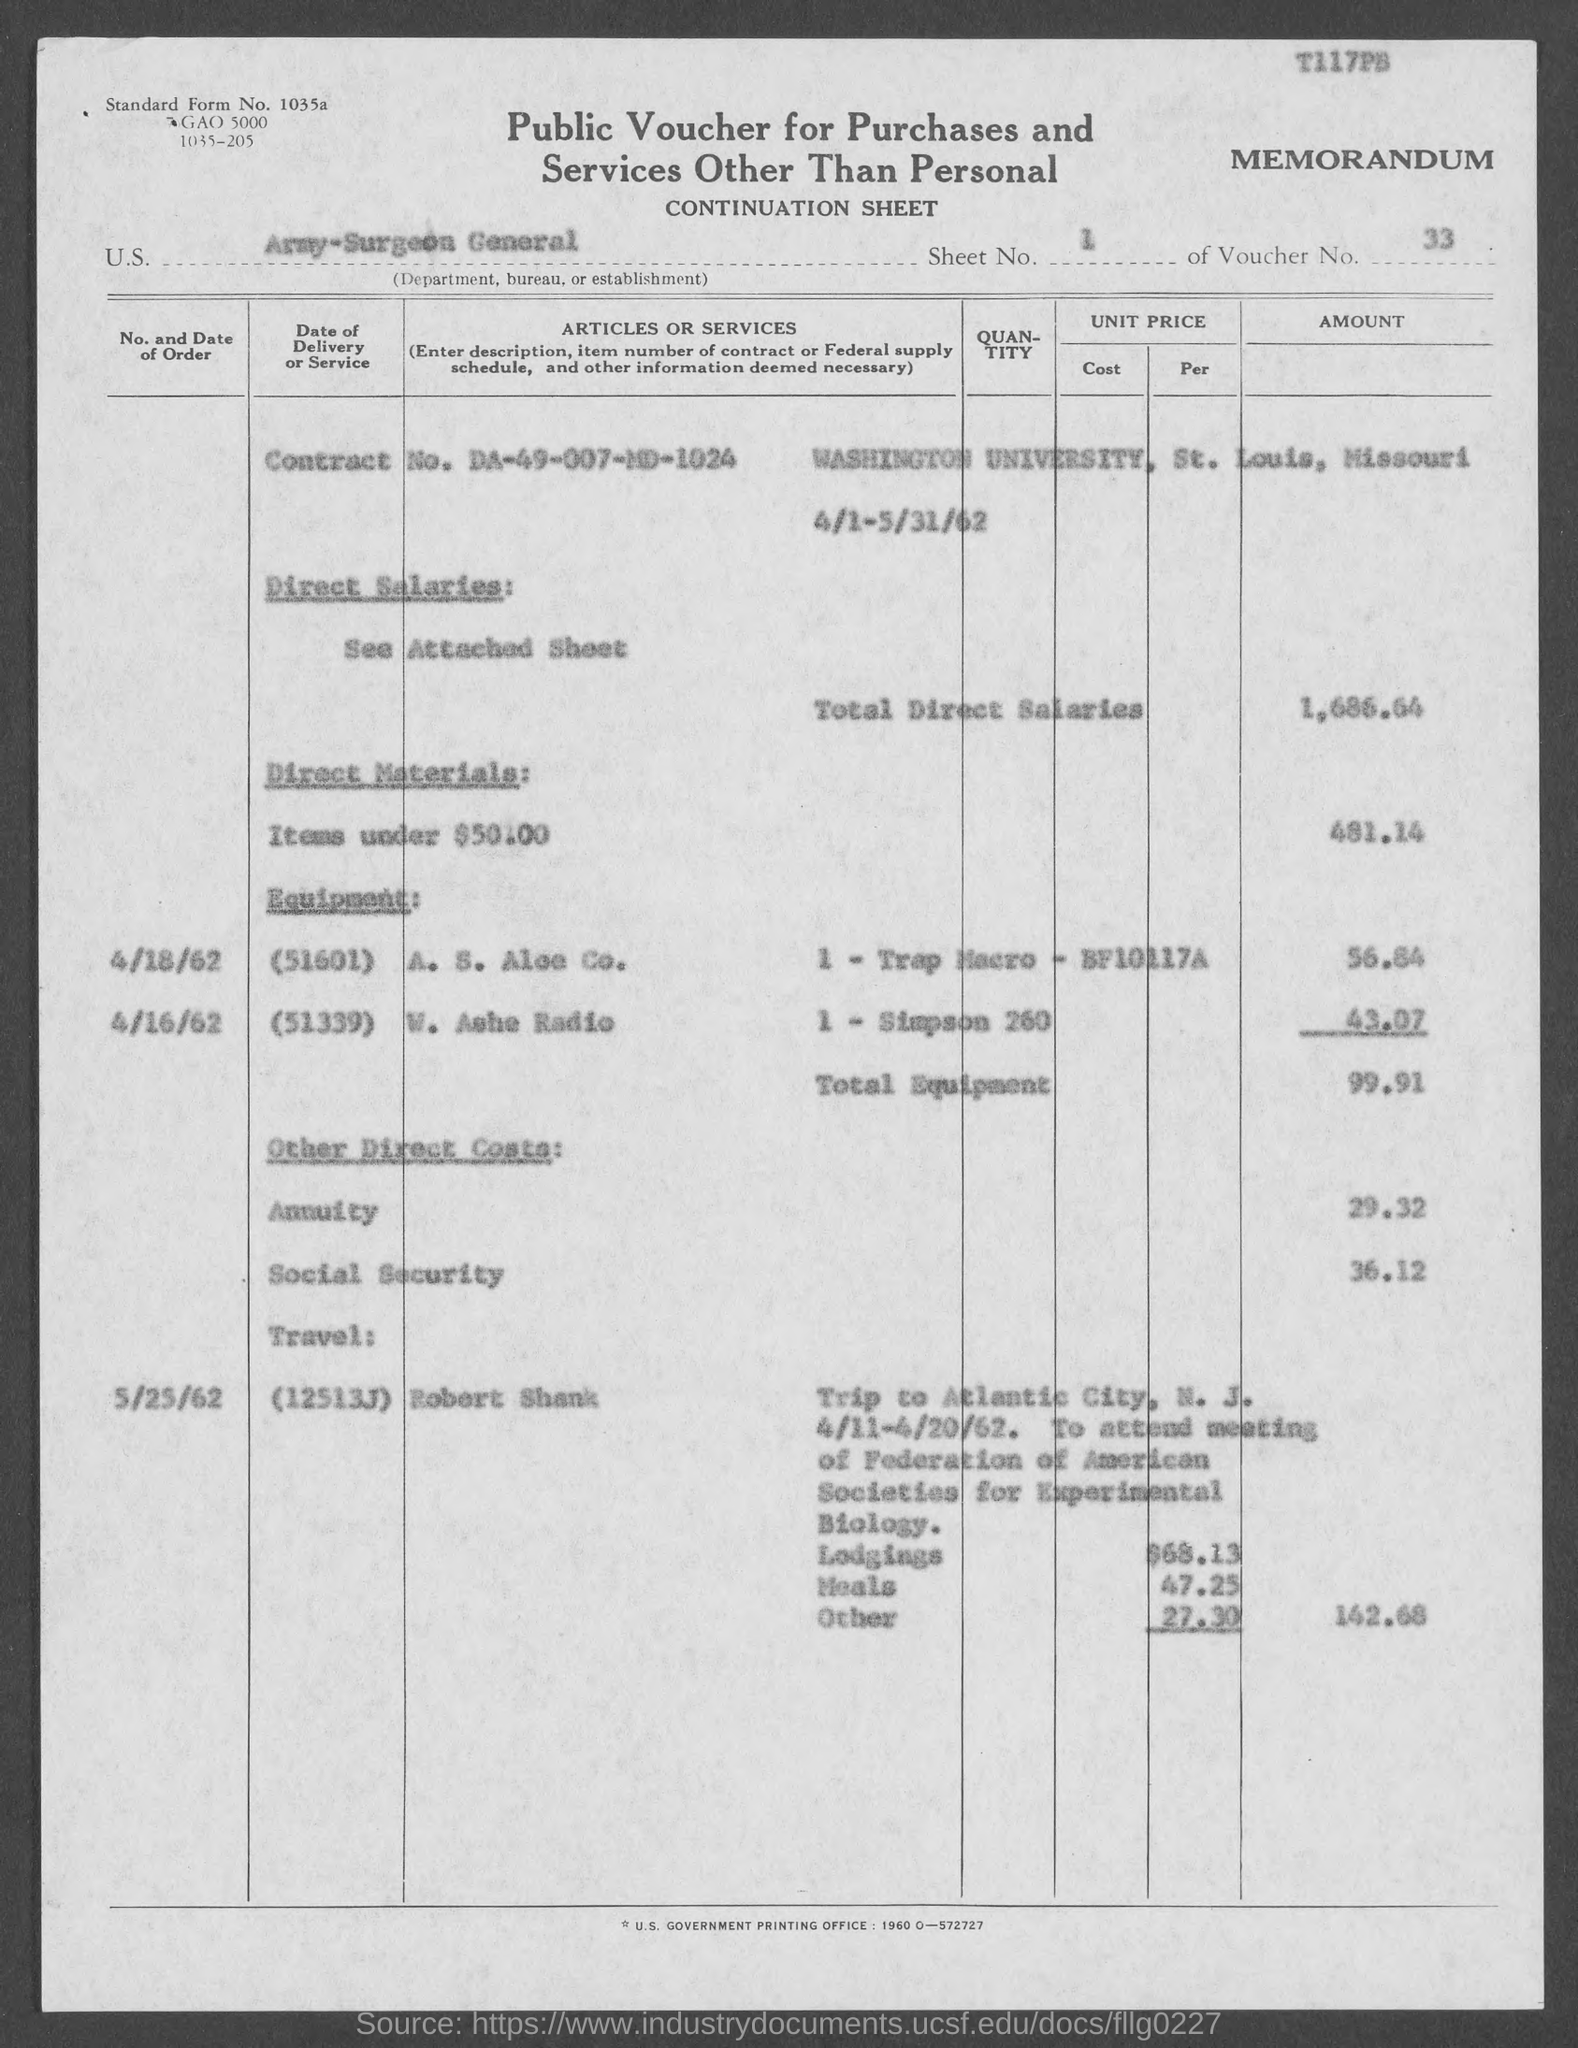Highlight a few significant elements in this photo. The voucher number is 33. The Contract No. is DA-49-007-MD-1024. The total direct salaries is 1,686.64 dollars. This document is a public voucher for purchases and services other than personal, which provides information about the nature and purpose of the transaction. What is sheet number 1? 